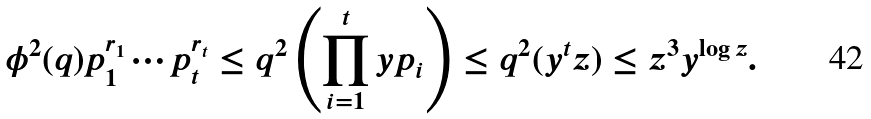<formula> <loc_0><loc_0><loc_500><loc_500>\phi ^ { 2 } ( q ) p _ { 1 } ^ { r _ { 1 } } \cdots p _ { t } ^ { r _ { t } } \leq q ^ { 2 } \left ( \prod _ { i = 1 } ^ { t } y p _ { i } \right ) \leq q ^ { 2 } ( y ^ { t } z ) \leq z ^ { 3 } y ^ { \log z } .</formula> 